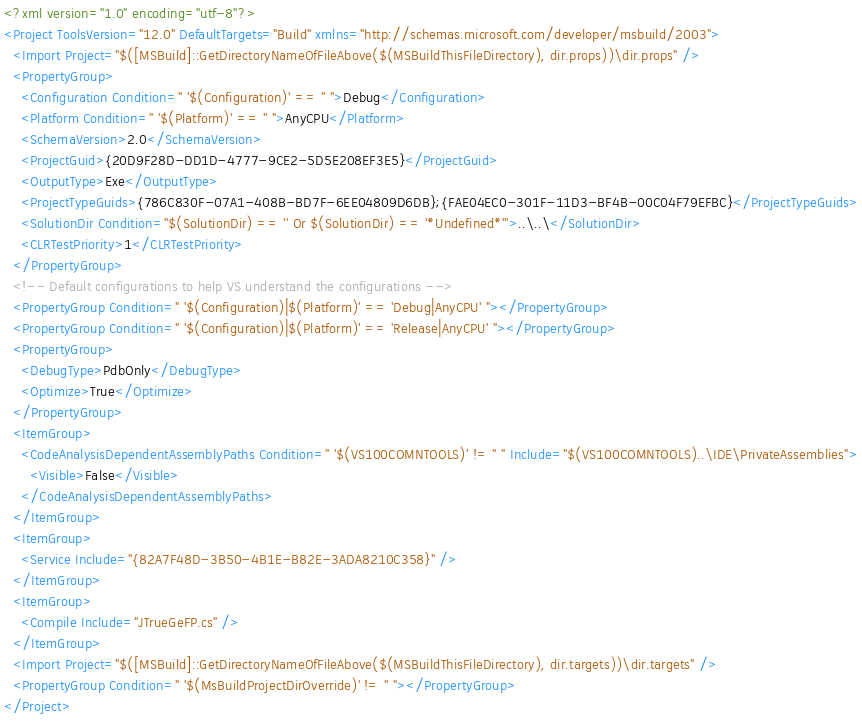Convert code to text. <code><loc_0><loc_0><loc_500><loc_500><_XML_><?xml version="1.0" encoding="utf-8"?>
<Project ToolsVersion="12.0" DefaultTargets="Build" xmlns="http://schemas.microsoft.com/developer/msbuild/2003">
  <Import Project="$([MSBuild]::GetDirectoryNameOfFileAbove($(MSBuildThisFileDirectory), dir.props))\dir.props" />
  <PropertyGroup>
    <Configuration Condition=" '$(Configuration)' == '' ">Debug</Configuration>
    <Platform Condition=" '$(Platform)' == '' ">AnyCPU</Platform>
    <SchemaVersion>2.0</SchemaVersion>
    <ProjectGuid>{20D9F28D-DD1D-4777-9CE2-5D5E208EF3E5}</ProjectGuid>
    <OutputType>Exe</OutputType>
    <ProjectTypeGuids>{786C830F-07A1-408B-BD7F-6EE04809D6DB};{FAE04EC0-301F-11D3-BF4B-00C04F79EFBC}</ProjectTypeGuids>
    <SolutionDir Condition="$(SolutionDir) == '' Or $(SolutionDir) == '*Undefined*'">..\..\</SolutionDir>
    <CLRTestPriority>1</CLRTestPriority>
  </PropertyGroup>
  <!-- Default configurations to help VS understand the configurations -->
  <PropertyGroup Condition=" '$(Configuration)|$(Platform)' == 'Debug|AnyCPU' "></PropertyGroup>
  <PropertyGroup Condition=" '$(Configuration)|$(Platform)' == 'Release|AnyCPU' "></PropertyGroup>
  <PropertyGroup>
    <DebugType>PdbOnly</DebugType>
    <Optimize>True</Optimize>
  </PropertyGroup>
  <ItemGroup>
    <CodeAnalysisDependentAssemblyPaths Condition=" '$(VS100COMNTOOLS)' != '' " Include="$(VS100COMNTOOLS)..\IDE\PrivateAssemblies">
      <Visible>False</Visible>
    </CodeAnalysisDependentAssemblyPaths>
  </ItemGroup>
  <ItemGroup>
    <Service Include="{82A7F48D-3B50-4B1E-B82E-3ADA8210C358}" />
  </ItemGroup>
  <ItemGroup>
    <Compile Include="JTrueGeFP.cs" />
  </ItemGroup>
  <Import Project="$([MSBuild]::GetDirectoryNameOfFileAbove($(MSBuildThisFileDirectory), dir.targets))\dir.targets" />
  <PropertyGroup Condition=" '$(MsBuildProjectDirOverride)' != '' "></PropertyGroup>
</Project></code> 